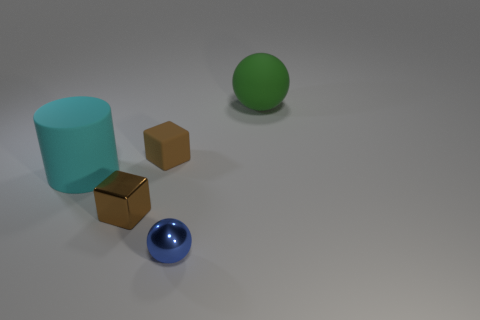How many brown objects are either rubber cylinders or small balls?
Offer a very short reply. 0. What is the color of the large rubber sphere?
Offer a very short reply. Green. The brown cube that is made of the same material as the large sphere is what size?
Give a very brief answer. Small. How many other cyan matte objects have the same shape as the small matte object?
Your answer should be very brief. 0. Is there anything else that has the same size as the blue object?
Your answer should be very brief. Yes. There is a ball that is in front of the large thing to the right of the large cyan thing; how big is it?
Offer a very short reply. Small. There is a ball that is the same size as the cyan thing; what is its material?
Give a very brief answer. Rubber. Is there a large green object made of the same material as the small ball?
Provide a succinct answer. No. There is a object that is behind the brown block to the right of the shiny thing behind the blue object; what color is it?
Your answer should be compact. Green. There is a ball in front of the green object; is its color the same as the ball behind the blue shiny ball?
Your answer should be compact. No. 